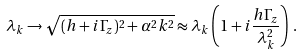Convert formula to latex. <formula><loc_0><loc_0><loc_500><loc_500>\lambda _ { k } \to \sqrt { ( h + i \Gamma _ { z } ) ^ { 2 } + \alpha ^ { 2 } k ^ { 2 } } \approx \lambda _ { k } \left ( 1 + i \frac { h \Gamma _ { z } } { \lambda _ { k } ^ { 2 } } \right ) \, .</formula> 